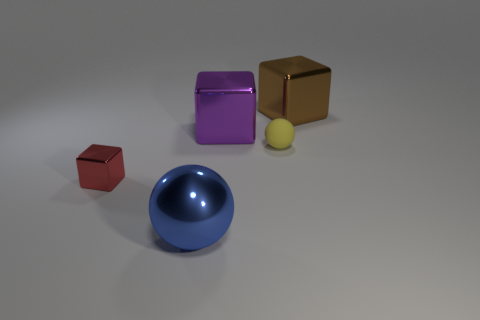What shape is the metallic object that is on the left side of the large metal ball? cube 